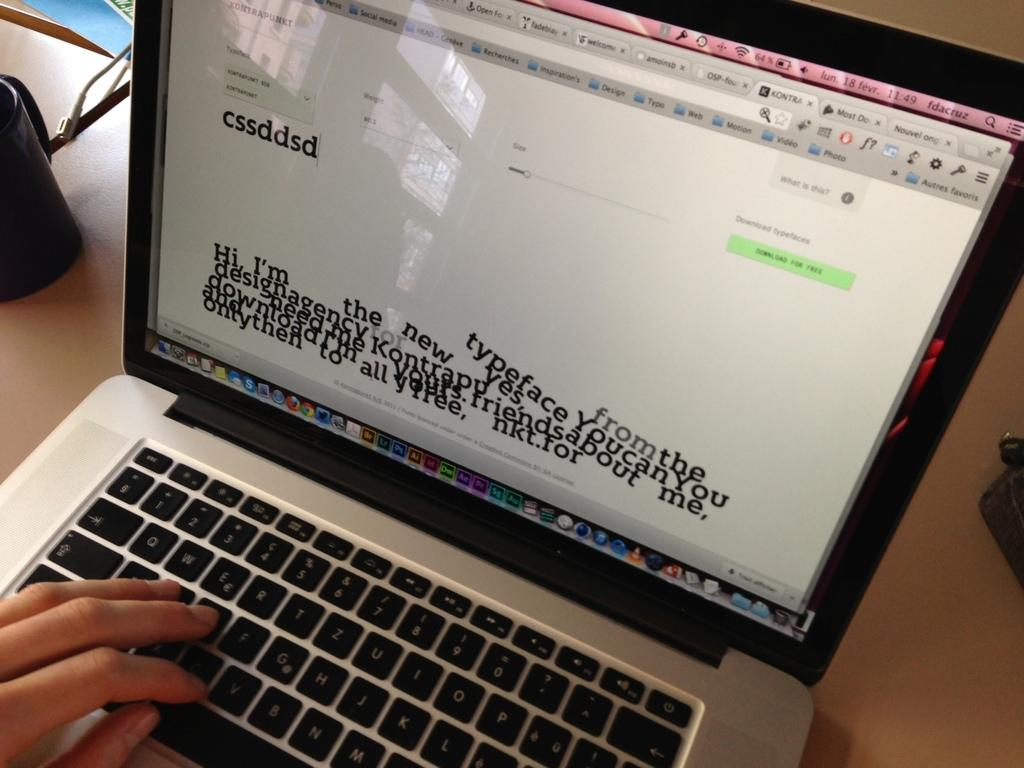<image>
Render a clear and concise summary of the photo. Person using a laptop with the word "cssddsd" on the screen. 